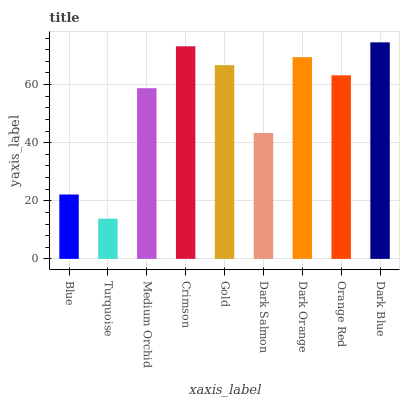Is Turquoise the minimum?
Answer yes or no. Yes. Is Dark Blue the maximum?
Answer yes or no. Yes. Is Medium Orchid the minimum?
Answer yes or no. No. Is Medium Orchid the maximum?
Answer yes or no. No. Is Medium Orchid greater than Turquoise?
Answer yes or no. Yes. Is Turquoise less than Medium Orchid?
Answer yes or no. Yes. Is Turquoise greater than Medium Orchid?
Answer yes or no. No. Is Medium Orchid less than Turquoise?
Answer yes or no. No. Is Orange Red the high median?
Answer yes or no. Yes. Is Orange Red the low median?
Answer yes or no. Yes. Is Medium Orchid the high median?
Answer yes or no. No. Is Turquoise the low median?
Answer yes or no. No. 